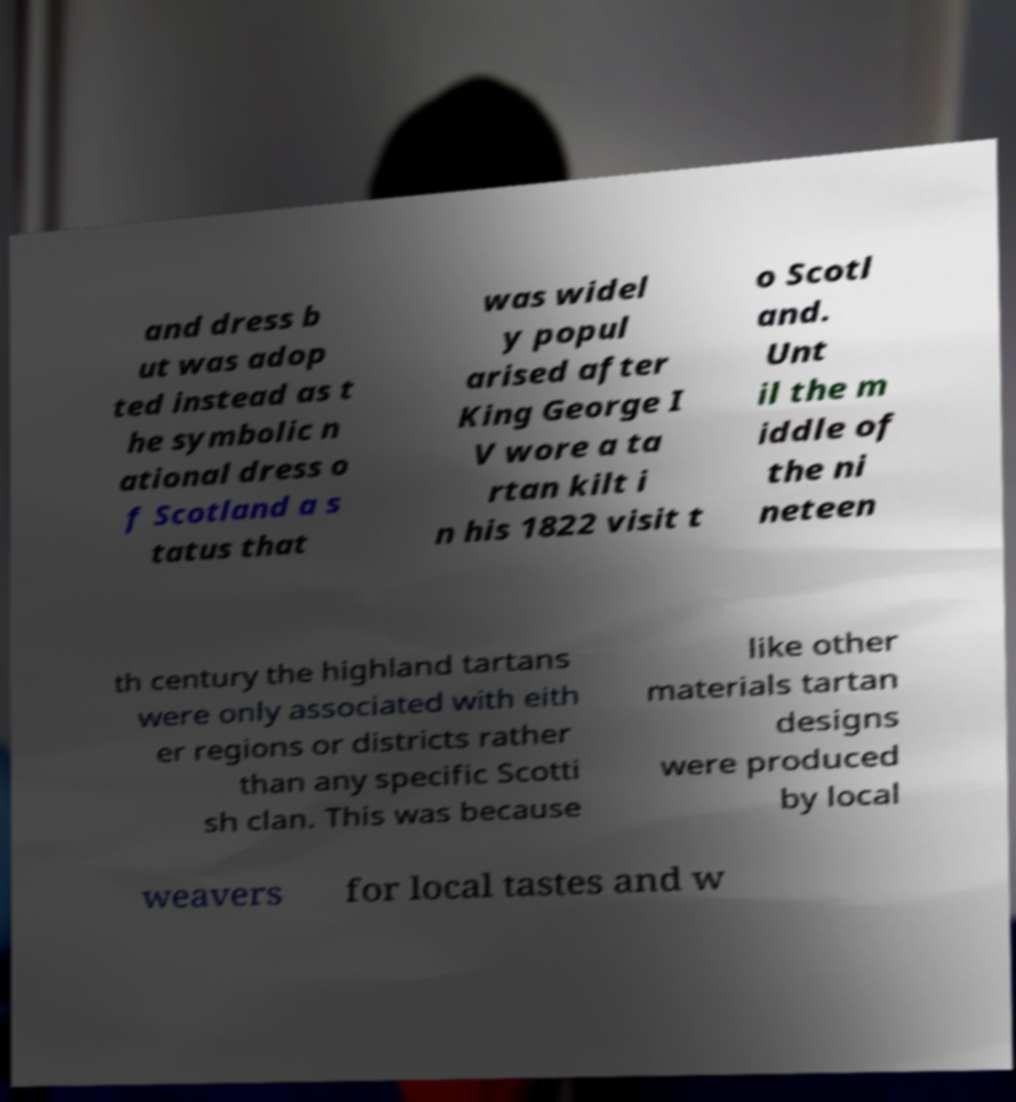Can you accurately transcribe the text from the provided image for me? and dress b ut was adop ted instead as t he symbolic n ational dress o f Scotland a s tatus that was widel y popul arised after King George I V wore a ta rtan kilt i n his 1822 visit t o Scotl and. Unt il the m iddle of the ni neteen th century the highland tartans were only associated with eith er regions or districts rather than any specific Scotti sh clan. This was because like other materials tartan designs were produced by local weavers for local tastes and w 